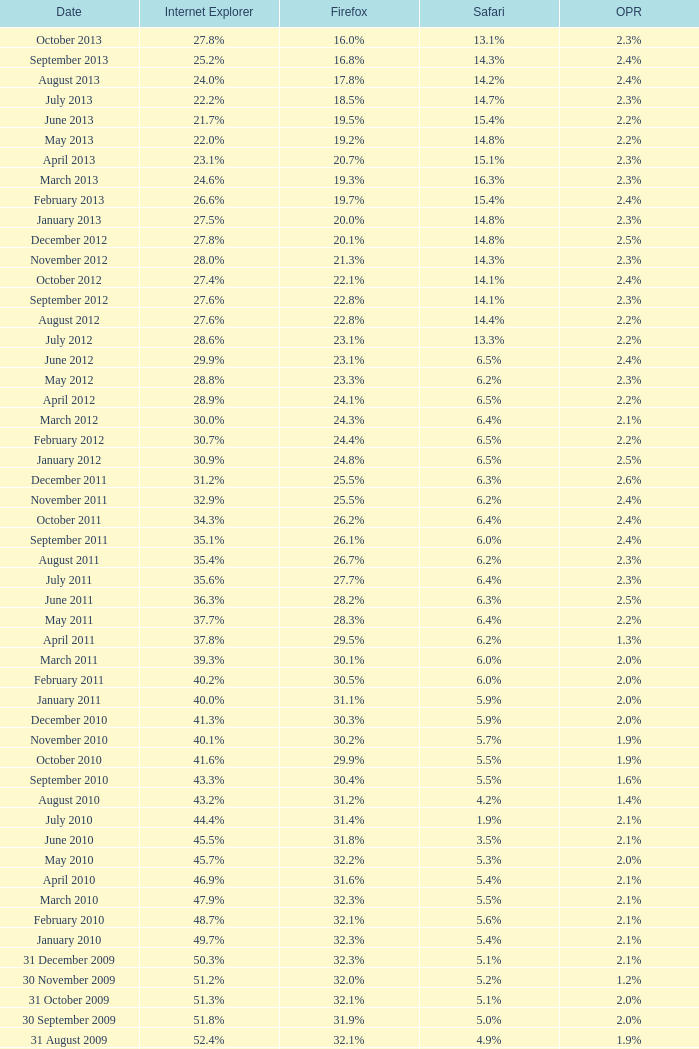What is the firefox value with a 1.9% safari? 31.4%. 